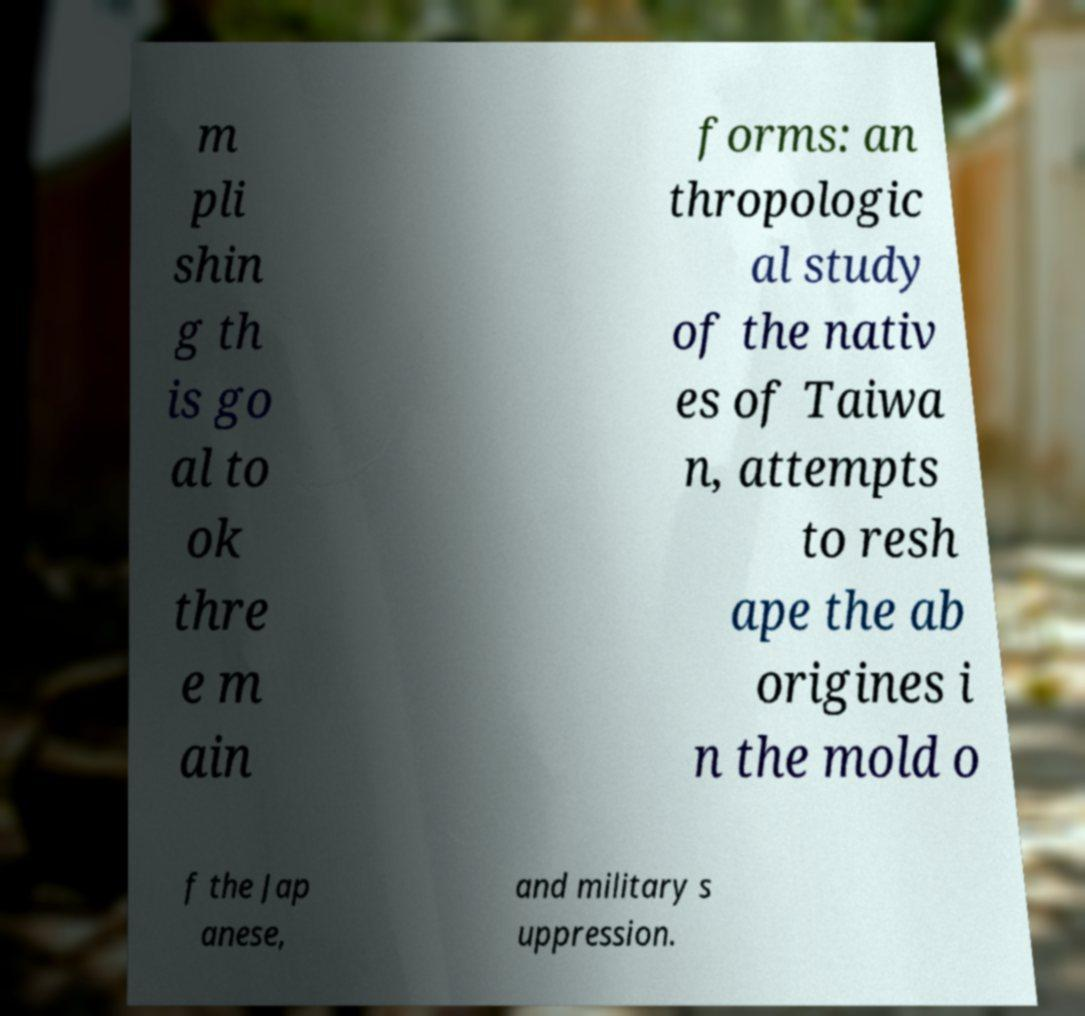Could you assist in decoding the text presented in this image and type it out clearly? m pli shin g th is go al to ok thre e m ain forms: an thropologic al study of the nativ es of Taiwa n, attempts to resh ape the ab origines i n the mold o f the Jap anese, and military s uppression. 